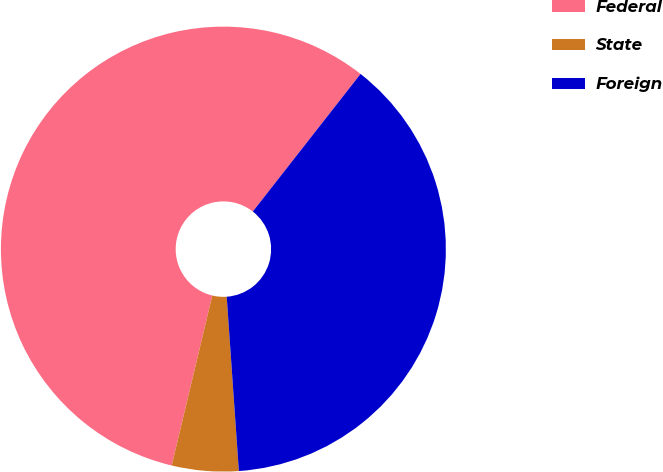Convert chart to OTSL. <chart><loc_0><loc_0><loc_500><loc_500><pie_chart><fcel>Federal<fcel>State<fcel>Foreign<nl><fcel>56.84%<fcel>4.84%<fcel>38.32%<nl></chart> 